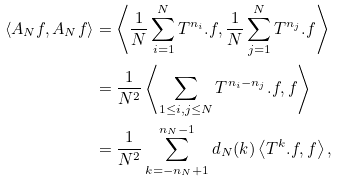Convert formula to latex. <formula><loc_0><loc_0><loc_500><loc_500>\left < A _ { N } f , A _ { N } f \right > & = \left < \frac { 1 } { N } \sum _ { i = 1 } ^ { N } T ^ { n _ { i } } . f , \frac { 1 } { N } \sum _ { j = 1 } ^ { N } T ^ { n _ { j } } . f \right > \\ & = \frac { 1 } { N ^ { 2 } } \left < \sum _ { 1 \leq i , j \leq N } T ^ { n _ { i } - n _ { j } } . f , f \right > \\ & = \frac { 1 } { N ^ { 2 } } \sum _ { k = - n _ { N } + 1 } ^ { n _ { N } - 1 } d _ { N } ( k ) \left < T ^ { k } . f , f \right > ,</formula> 